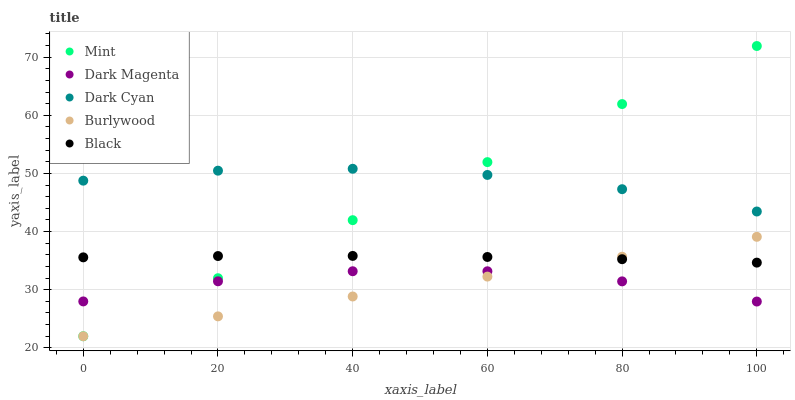Does Burlywood have the minimum area under the curve?
Answer yes or no. Yes. Does Dark Cyan have the maximum area under the curve?
Answer yes or no. Yes. Does Mint have the minimum area under the curve?
Answer yes or no. No. Does Mint have the maximum area under the curve?
Answer yes or no. No. Is Burlywood the smoothest?
Answer yes or no. Yes. Is Dark Magenta the roughest?
Answer yes or no. Yes. Is Mint the smoothest?
Answer yes or no. No. Is Mint the roughest?
Answer yes or no. No. Does Burlywood have the lowest value?
Answer yes or no. Yes. Does Dark Magenta have the lowest value?
Answer yes or no. No. Does Mint have the highest value?
Answer yes or no. Yes. Does Burlywood have the highest value?
Answer yes or no. No. Is Burlywood less than Dark Cyan?
Answer yes or no. Yes. Is Dark Cyan greater than Dark Magenta?
Answer yes or no. Yes. Does Mint intersect Black?
Answer yes or no. Yes. Is Mint less than Black?
Answer yes or no. No. Is Mint greater than Black?
Answer yes or no. No. Does Burlywood intersect Dark Cyan?
Answer yes or no. No. 